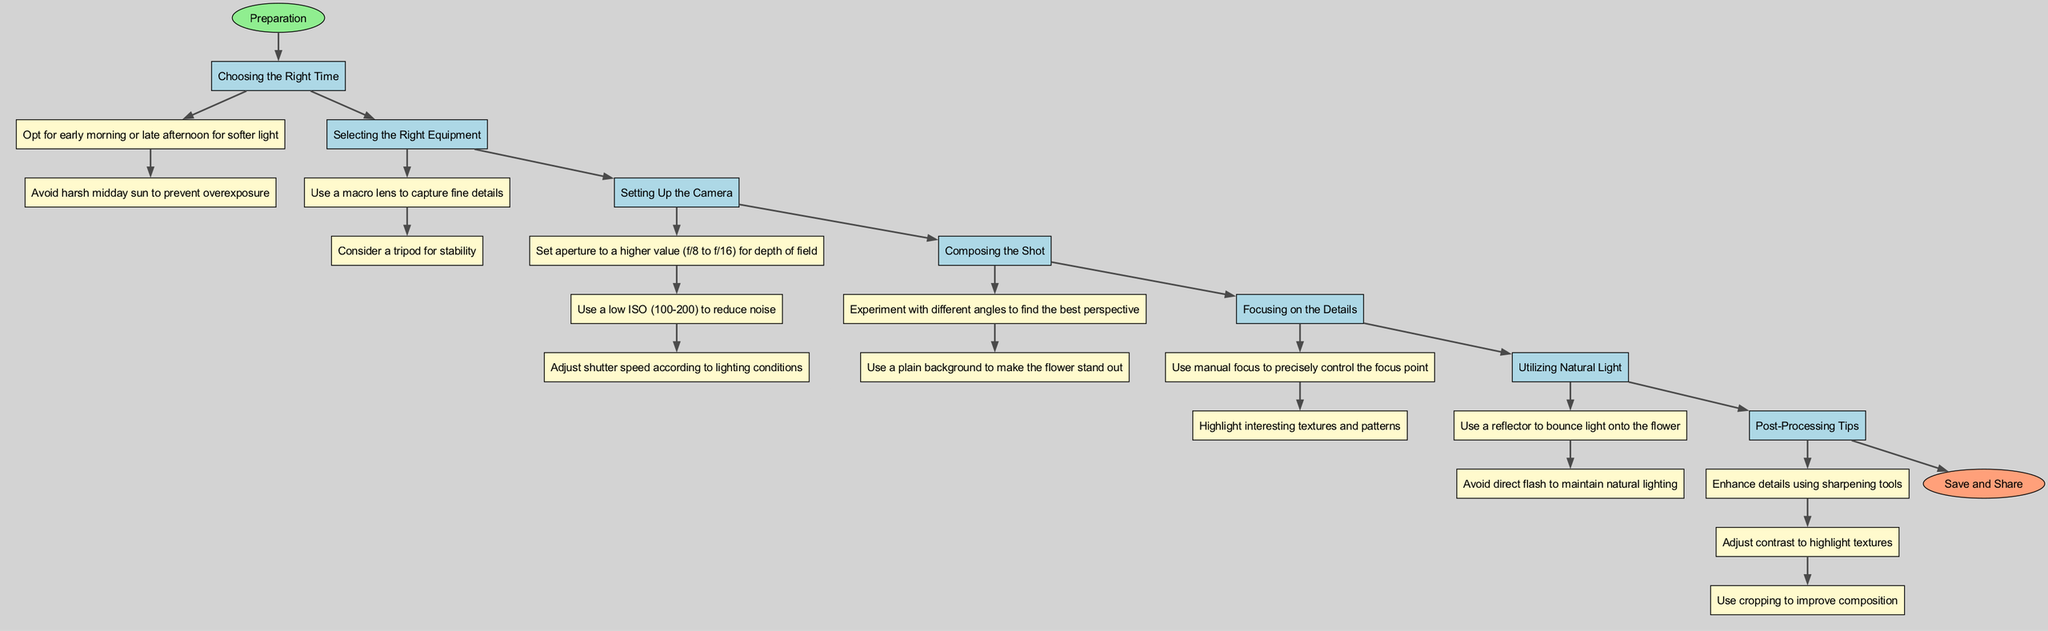What is the first step in the diagram? The first step after the start node is labeled "Preparation," which is the overarching theme of the diagram. Since it is directly connected to the start node, it can be identified as the initial step.
Answer: Preparation How many elements are listed in the diagram? The diagram includes 7 elements, which are represented as nodes between the start and end nodes. Each of these elements represents a technique for capturing flower details and textures.
Answer: 7 What technique is recommended to utilize natural light? The technique listed under "Utilizing Natural Light" specifies to "Use a reflector to bounce light onto the flower." This is a specific detail provided in the instructions for ensuring effective use of natural light during photography.
Answer: Use a reflector to bounce light onto the flower What is the last step before saving and sharing? The last step connecting to the end node is "Post-Processing Tips," which are recommendations for refining the photograph after it has been taken. It is the final instructional node before the conclusion of the diagram.
Answer: Post-Processing Tips Which element suggests using a macro lens? The element "Selecting the Right Equipment" contains the suggestion to "Use a macro lens to capture fine details," making it clear that this particular technique includes the use of a specific type of lens for macro photography.
Answer: Selecting the Right Equipment How many details are provided under "Composing the Shot"? The details under "Composing the Shot" include 2 specific points, both of which guide the photographer on how to arrange their shot effectively. This requires counting the individual points listed beneath this specific technique node.
Answer: 2 Which technique focuses on highlighting textures and patterns? The element dedicated to emphasizing this aspect is "Focusing on the Details," which explicitly mentions that one should "Highlight interesting textures and patterns," identifying it as the technique concerned with detail capture.
Answer: Focusing on the Details What aperture settings are recommended for depth of field? The suggested aperture settings outlined under "Setting Up the Camera" are f/8 to f/16, which are specifically indicated as settings to enhance depth of field when photographing flowers.
Answer: f/8 to f/16 How are the nodes connected in the diagram? The nodes are sequentially connected from the start through each element in a linear progression, ultimately connecting to the end node. This indicates a step-by-step approach to the techniques laid out in the diagram.
Answer: Sequentially connected 